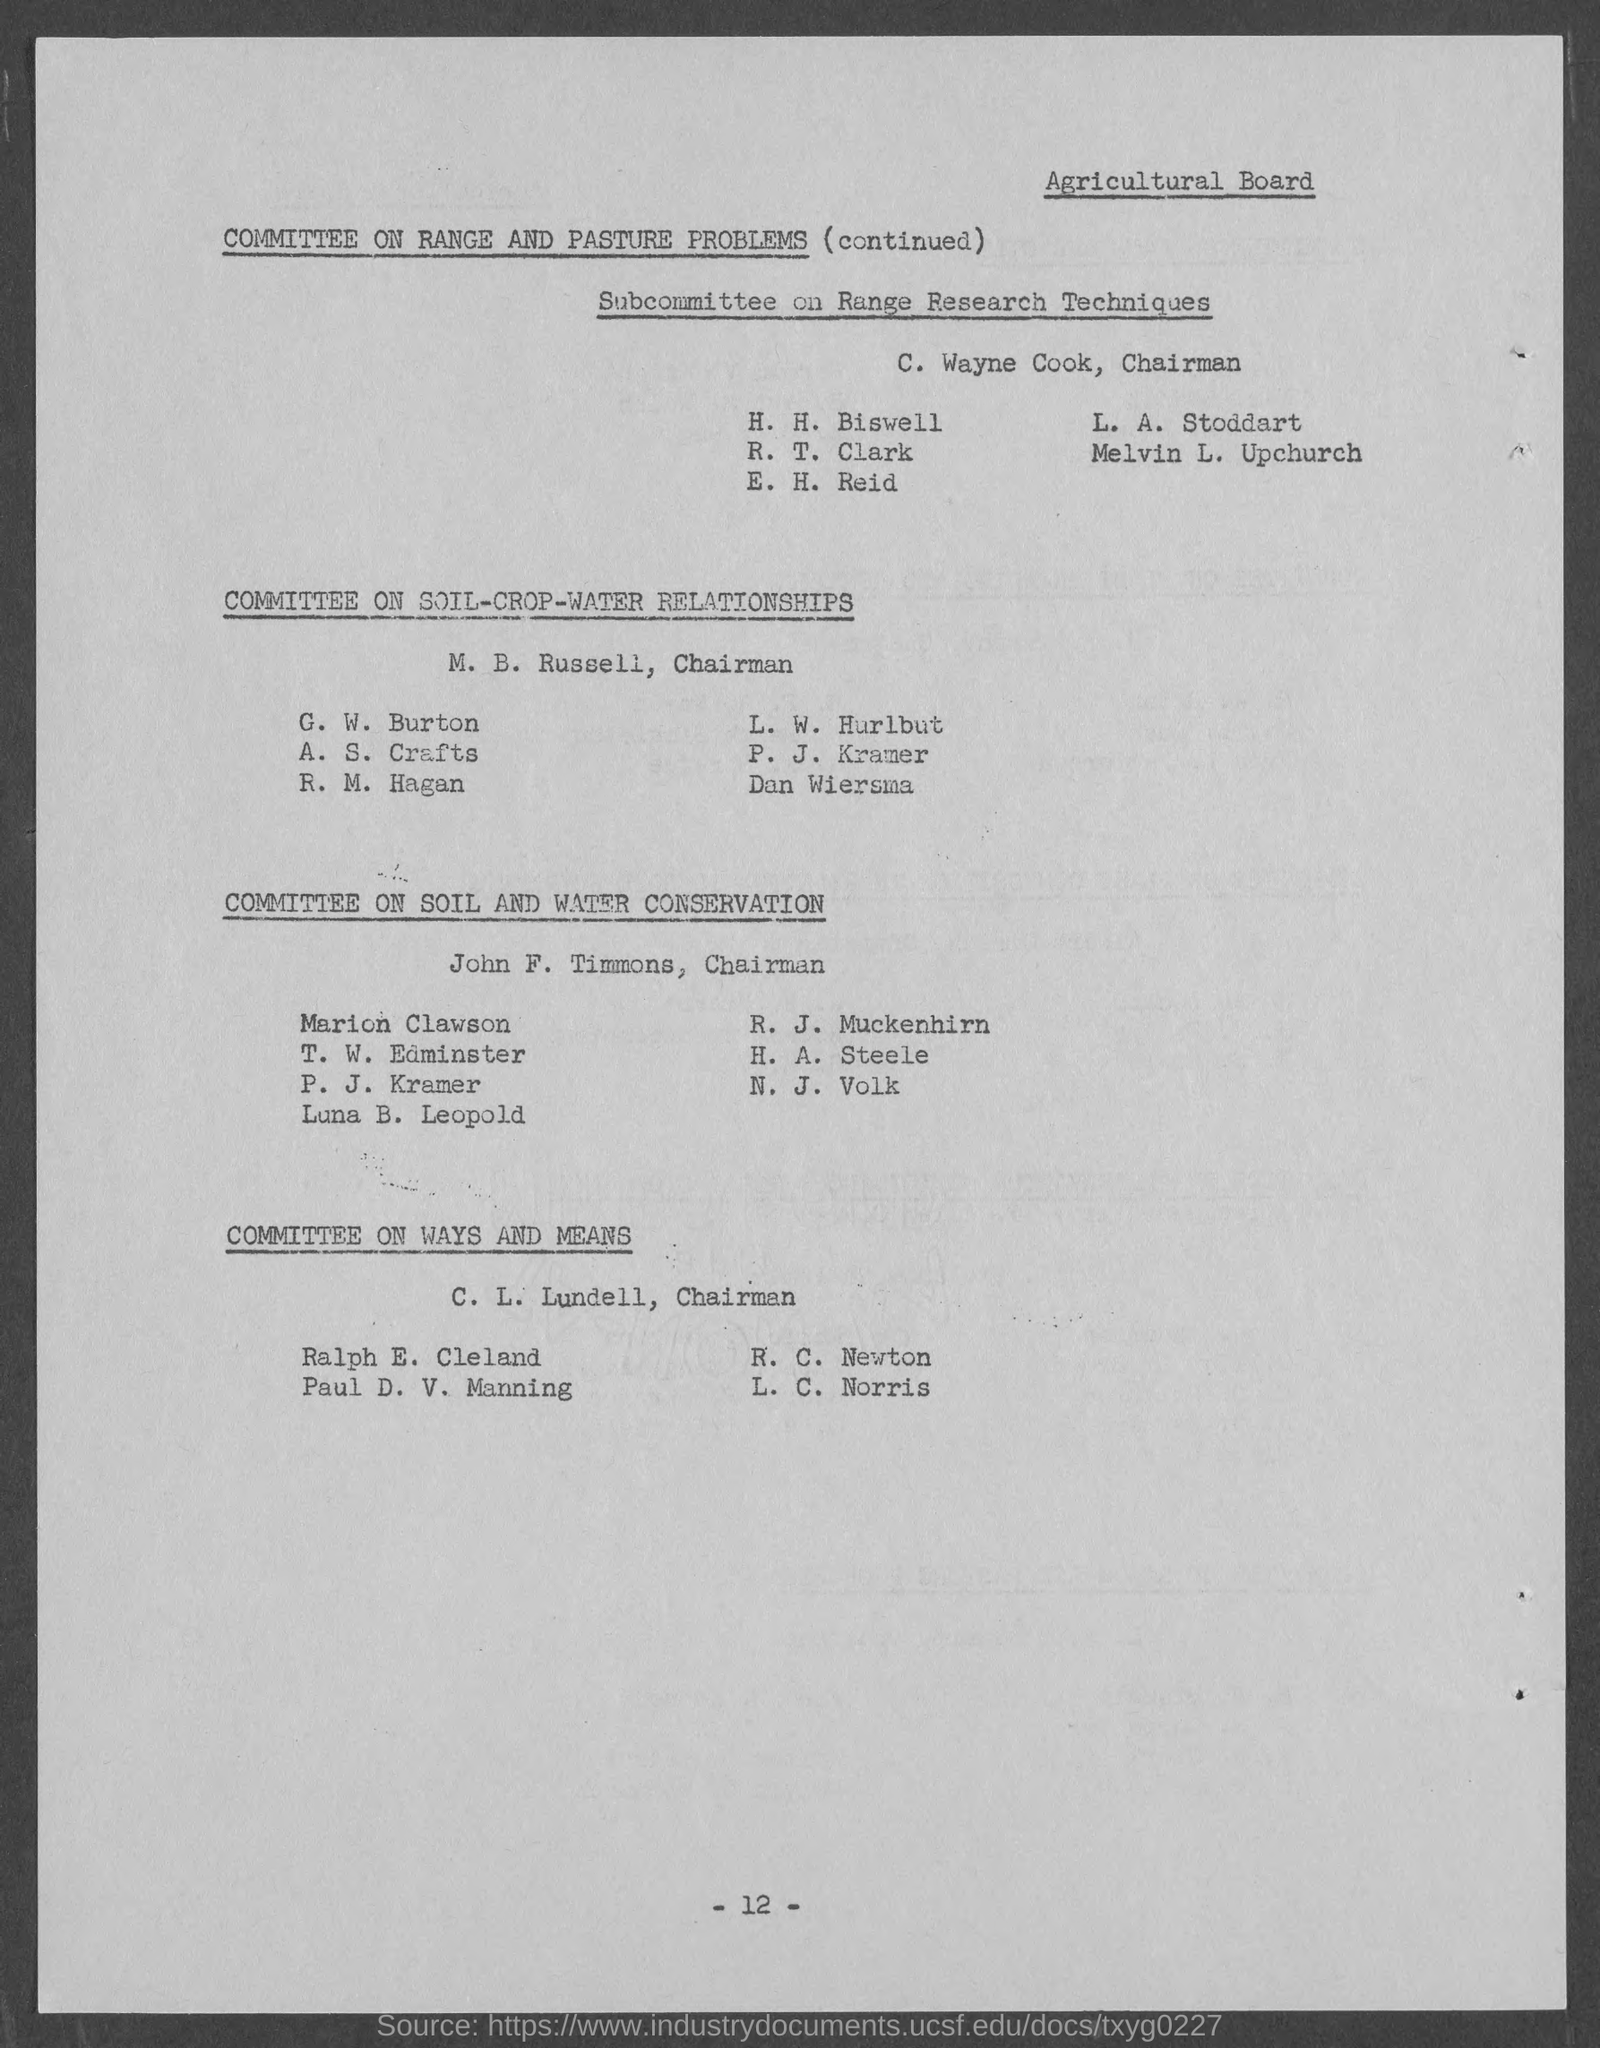Who is the chairman of subcommittee on range research techniques?
Your answer should be compact. C. Wayne Cook. Who is the Chairman of committee of ways and means?
Offer a terse response. C. L. Lundell. Who is the chairman of committee on soil and water conservation?
Your response must be concise. John F. Timmons. What is the page no mentioned in this document?
Your response must be concise. - 12 -. 